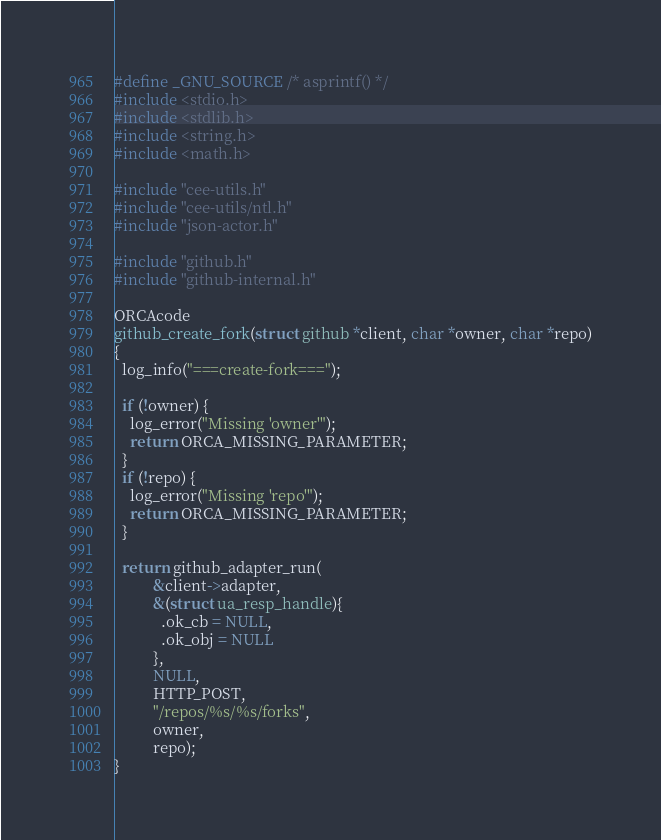Convert code to text. <code><loc_0><loc_0><loc_500><loc_500><_C_>#define _GNU_SOURCE /* asprintf() */
#include <stdio.h>
#include <stdlib.h>
#include <string.h>
#include <math.h>

#include "cee-utils.h"
#include "cee-utils/ntl.h"
#include "json-actor.h"

#include "github.h"
#include "github-internal.h"

ORCAcode
github_create_fork(struct github *client, char *owner, char *repo)
{
  log_info("===create-fork===");

  if (!owner) {
    log_error("Missing 'owner'");
    return ORCA_MISSING_PARAMETER;
  }
  if (!repo) {
    log_error("Missing 'repo'");
    return ORCA_MISSING_PARAMETER;
  }

  return github_adapter_run(
          &client->adapter,
          &(struct ua_resp_handle){
            .ok_cb = NULL,
            .ok_obj = NULL
          },
          NULL,
          HTTP_POST,
          "/repos/%s/%s/forks",
          owner,
          repo);
}
</code> 